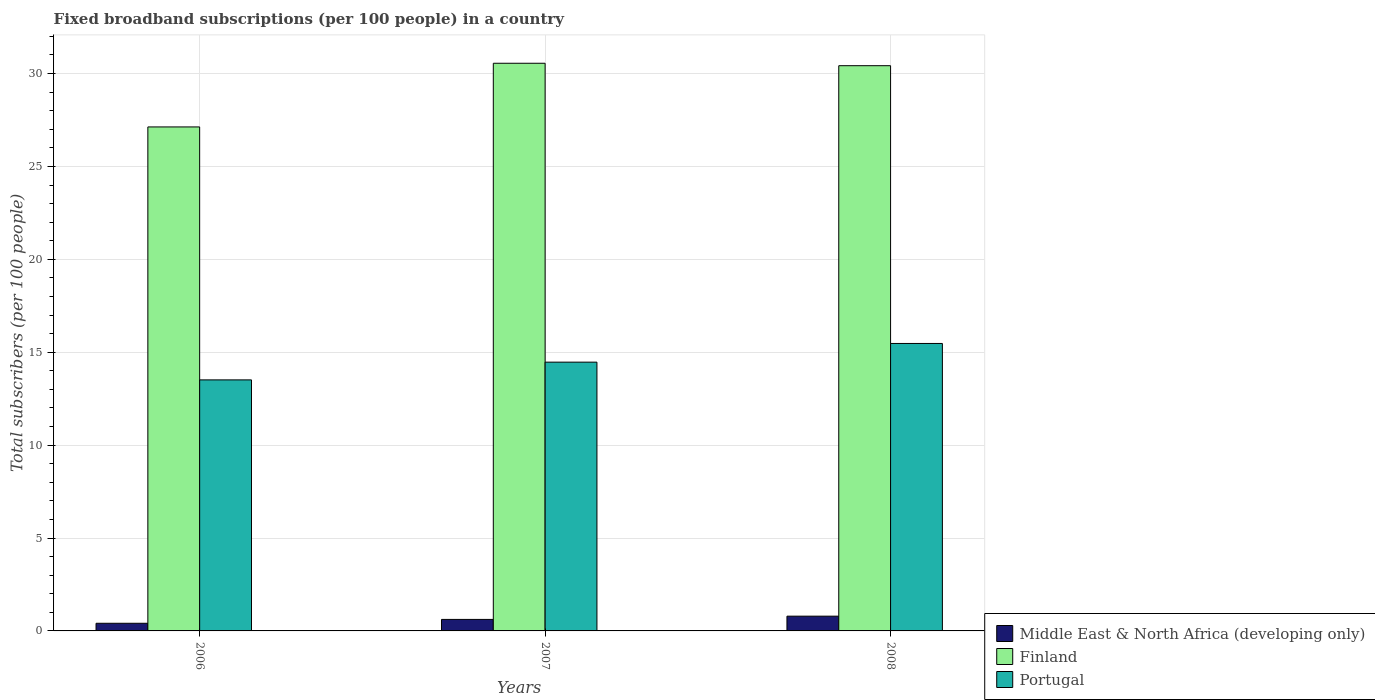How many different coloured bars are there?
Offer a very short reply. 3. Are the number of bars on each tick of the X-axis equal?
Provide a short and direct response. Yes. How many bars are there on the 3rd tick from the right?
Offer a very short reply. 3. What is the number of broadband subscriptions in Portugal in 2006?
Provide a short and direct response. 13.51. Across all years, what is the maximum number of broadband subscriptions in Finland?
Keep it short and to the point. 30.55. Across all years, what is the minimum number of broadband subscriptions in Finland?
Offer a very short reply. 27.13. What is the total number of broadband subscriptions in Middle East & North Africa (developing only) in the graph?
Provide a succinct answer. 1.83. What is the difference between the number of broadband subscriptions in Middle East & North Africa (developing only) in 2007 and that in 2008?
Keep it short and to the point. -0.18. What is the difference between the number of broadband subscriptions in Middle East & North Africa (developing only) in 2007 and the number of broadband subscriptions in Portugal in 2008?
Make the answer very short. -14.85. What is the average number of broadband subscriptions in Middle East & North Africa (developing only) per year?
Provide a succinct answer. 0.61. In the year 2006, what is the difference between the number of broadband subscriptions in Finland and number of broadband subscriptions in Middle East & North Africa (developing only)?
Provide a succinct answer. 26.71. In how many years, is the number of broadband subscriptions in Portugal greater than 20?
Provide a short and direct response. 0. What is the ratio of the number of broadband subscriptions in Middle East & North Africa (developing only) in 2006 to that in 2008?
Offer a terse response. 0.52. What is the difference between the highest and the second highest number of broadband subscriptions in Finland?
Ensure brevity in your answer.  0.13. What is the difference between the highest and the lowest number of broadband subscriptions in Finland?
Keep it short and to the point. 3.43. In how many years, is the number of broadband subscriptions in Middle East & North Africa (developing only) greater than the average number of broadband subscriptions in Middle East & North Africa (developing only) taken over all years?
Ensure brevity in your answer.  2. Is the sum of the number of broadband subscriptions in Finland in 2006 and 2008 greater than the maximum number of broadband subscriptions in Portugal across all years?
Offer a very short reply. Yes. What does the 2nd bar from the left in 2006 represents?
Make the answer very short. Finland. What does the 3rd bar from the right in 2008 represents?
Ensure brevity in your answer.  Middle East & North Africa (developing only). How many bars are there?
Provide a short and direct response. 9. Are all the bars in the graph horizontal?
Provide a succinct answer. No. How many years are there in the graph?
Keep it short and to the point. 3. Are the values on the major ticks of Y-axis written in scientific E-notation?
Provide a short and direct response. No. What is the title of the graph?
Your answer should be compact. Fixed broadband subscriptions (per 100 people) in a country. Does "Solomon Islands" appear as one of the legend labels in the graph?
Keep it short and to the point. No. What is the label or title of the Y-axis?
Provide a succinct answer. Total subscribers (per 100 people). What is the Total subscribers (per 100 people) of Middle East & North Africa (developing only) in 2006?
Offer a very short reply. 0.41. What is the Total subscribers (per 100 people) in Finland in 2006?
Ensure brevity in your answer.  27.13. What is the Total subscribers (per 100 people) of Portugal in 2006?
Keep it short and to the point. 13.51. What is the Total subscribers (per 100 people) of Middle East & North Africa (developing only) in 2007?
Provide a short and direct response. 0.62. What is the Total subscribers (per 100 people) of Finland in 2007?
Ensure brevity in your answer.  30.55. What is the Total subscribers (per 100 people) of Portugal in 2007?
Offer a terse response. 14.47. What is the Total subscribers (per 100 people) in Middle East & North Africa (developing only) in 2008?
Provide a succinct answer. 0.79. What is the Total subscribers (per 100 people) of Finland in 2008?
Provide a succinct answer. 30.42. What is the Total subscribers (per 100 people) in Portugal in 2008?
Your answer should be compact. 15.47. Across all years, what is the maximum Total subscribers (per 100 people) of Middle East & North Africa (developing only)?
Your answer should be compact. 0.79. Across all years, what is the maximum Total subscribers (per 100 people) of Finland?
Offer a terse response. 30.55. Across all years, what is the maximum Total subscribers (per 100 people) in Portugal?
Provide a short and direct response. 15.47. Across all years, what is the minimum Total subscribers (per 100 people) in Middle East & North Africa (developing only)?
Offer a very short reply. 0.41. Across all years, what is the minimum Total subscribers (per 100 people) in Finland?
Make the answer very short. 27.13. Across all years, what is the minimum Total subscribers (per 100 people) in Portugal?
Your answer should be very brief. 13.51. What is the total Total subscribers (per 100 people) in Middle East & North Africa (developing only) in the graph?
Keep it short and to the point. 1.83. What is the total Total subscribers (per 100 people) of Finland in the graph?
Keep it short and to the point. 88.1. What is the total Total subscribers (per 100 people) in Portugal in the graph?
Your answer should be compact. 43.45. What is the difference between the Total subscribers (per 100 people) in Middle East & North Africa (developing only) in 2006 and that in 2007?
Give a very brief answer. -0.21. What is the difference between the Total subscribers (per 100 people) in Finland in 2006 and that in 2007?
Offer a terse response. -3.43. What is the difference between the Total subscribers (per 100 people) in Portugal in 2006 and that in 2007?
Your answer should be compact. -0.95. What is the difference between the Total subscribers (per 100 people) of Middle East & North Africa (developing only) in 2006 and that in 2008?
Offer a terse response. -0.38. What is the difference between the Total subscribers (per 100 people) of Finland in 2006 and that in 2008?
Offer a terse response. -3.3. What is the difference between the Total subscribers (per 100 people) in Portugal in 2006 and that in 2008?
Give a very brief answer. -1.96. What is the difference between the Total subscribers (per 100 people) of Middle East & North Africa (developing only) in 2007 and that in 2008?
Offer a very short reply. -0.18. What is the difference between the Total subscribers (per 100 people) of Finland in 2007 and that in 2008?
Give a very brief answer. 0.13. What is the difference between the Total subscribers (per 100 people) in Portugal in 2007 and that in 2008?
Provide a succinct answer. -1.01. What is the difference between the Total subscribers (per 100 people) of Middle East & North Africa (developing only) in 2006 and the Total subscribers (per 100 people) of Finland in 2007?
Your response must be concise. -30.14. What is the difference between the Total subscribers (per 100 people) in Middle East & North Africa (developing only) in 2006 and the Total subscribers (per 100 people) in Portugal in 2007?
Offer a very short reply. -14.05. What is the difference between the Total subscribers (per 100 people) of Finland in 2006 and the Total subscribers (per 100 people) of Portugal in 2007?
Offer a very short reply. 12.66. What is the difference between the Total subscribers (per 100 people) of Middle East & North Africa (developing only) in 2006 and the Total subscribers (per 100 people) of Finland in 2008?
Offer a very short reply. -30.01. What is the difference between the Total subscribers (per 100 people) of Middle East & North Africa (developing only) in 2006 and the Total subscribers (per 100 people) of Portugal in 2008?
Give a very brief answer. -15.06. What is the difference between the Total subscribers (per 100 people) in Finland in 2006 and the Total subscribers (per 100 people) in Portugal in 2008?
Keep it short and to the point. 11.65. What is the difference between the Total subscribers (per 100 people) of Middle East & North Africa (developing only) in 2007 and the Total subscribers (per 100 people) of Finland in 2008?
Ensure brevity in your answer.  -29.8. What is the difference between the Total subscribers (per 100 people) of Middle East & North Africa (developing only) in 2007 and the Total subscribers (per 100 people) of Portugal in 2008?
Make the answer very short. -14.85. What is the difference between the Total subscribers (per 100 people) in Finland in 2007 and the Total subscribers (per 100 people) in Portugal in 2008?
Provide a succinct answer. 15.08. What is the average Total subscribers (per 100 people) in Middle East & North Africa (developing only) per year?
Ensure brevity in your answer.  0.61. What is the average Total subscribers (per 100 people) in Finland per year?
Provide a succinct answer. 29.37. What is the average Total subscribers (per 100 people) in Portugal per year?
Provide a short and direct response. 14.48. In the year 2006, what is the difference between the Total subscribers (per 100 people) in Middle East & North Africa (developing only) and Total subscribers (per 100 people) in Finland?
Keep it short and to the point. -26.71. In the year 2006, what is the difference between the Total subscribers (per 100 people) of Middle East & North Africa (developing only) and Total subscribers (per 100 people) of Portugal?
Provide a short and direct response. -13.1. In the year 2006, what is the difference between the Total subscribers (per 100 people) of Finland and Total subscribers (per 100 people) of Portugal?
Your response must be concise. 13.62. In the year 2007, what is the difference between the Total subscribers (per 100 people) of Middle East & North Africa (developing only) and Total subscribers (per 100 people) of Finland?
Your answer should be very brief. -29.94. In the year 2007, what is the difference between the Total subscribers (per 100 people) of Middle East & North Africa (developing only) and Total subscribers (per 100 people) of Portugal?
Offer a terse response. -13.85. In the year 2007, what is the difference between the Total subscribers (per 100 people) of Finland and Total subscribers (per 100 people) of Portugal?
Provide a succinct answer. 16.09. In the year 2008, what is the difference between the Total subscribers (per 100 people) of Middle East & North Africa (developing only) and Total subscribers (per 100 people) of Finland?
Offer a terse response. -29.63. In the year 2008, what is the difference between the Total subscribers (per 100 people) of Middle East & North Africa (developing only) and Total subscribers (per 100 people) of Portugal?
Offer a terse response. -14.68. In the year 2008, what is the difference between the Total subscribers (per 100 people) in Finland and Total subscribers (per 100 people) in Portugal?
Provide a succinct answer. 14.95. What is the ratio of the Total subscribers (per 100 people) of Middle East & North Africa (developing only) in 2006 to that in 2007?
Provide a short and direct response. 0.67. What is the ratio of the Total subscribers (per 100 people) in Finland in 2006 to that in 2007?
Offer a very short reply. 0.89. What is the ratio of the Total subscribers (per 100 people) in Portugal in 2006 to that in 2007?
Your response must be concise. 0.93. What is the ratio of the Total subscribers (per 100 people) in Middle East & North Africa (developing only) in 2006 to that in 2008?
Offer a terse response. 0.52. What is the ratio of the Total subscribers (per 100 people) of Finland in 2006 to that in 2008?
Your response must be concise. 0.89. What is the ratio of the Total subscribers (per 100 people) in Portugal in 2006 to that in 2008?
Offer a terse response. 0.87. What is the ratio of the Total subscribers (per 100 people) in Middle East & North Africa (developing only) in 2007 to that in 2008?
Offer a terse response. 0.78. What is the ratio of the Total subscribers (per 100 people) in Portugal in 2007 to that in 2008?
Your answer should be very brief. 0.94. What is the difference between the highest and the second highest Total subscribers (per 100 people) of Middle East & North Africa (developing only)?
Keep it short and to the point. 0.18. What is the difference between the highest and the second highest Total subscribers (per 100 people) of Finland?
Offer a very short reply. 0.13. What is the difference between the highest and the lowest Total subscribers (per 100 people) in Middle East & North Africa (developing only)?
Your answer should be very brief. 0.38. What is the difference between the highest and the lowest Total subscribers (per 100 people) of Finland?
Your answer should be very brief. 3.43. What is the difference between the highest and the lowest Total subscribers (per 100 people) in Portugal?
Offer a terse response. 1.96. 